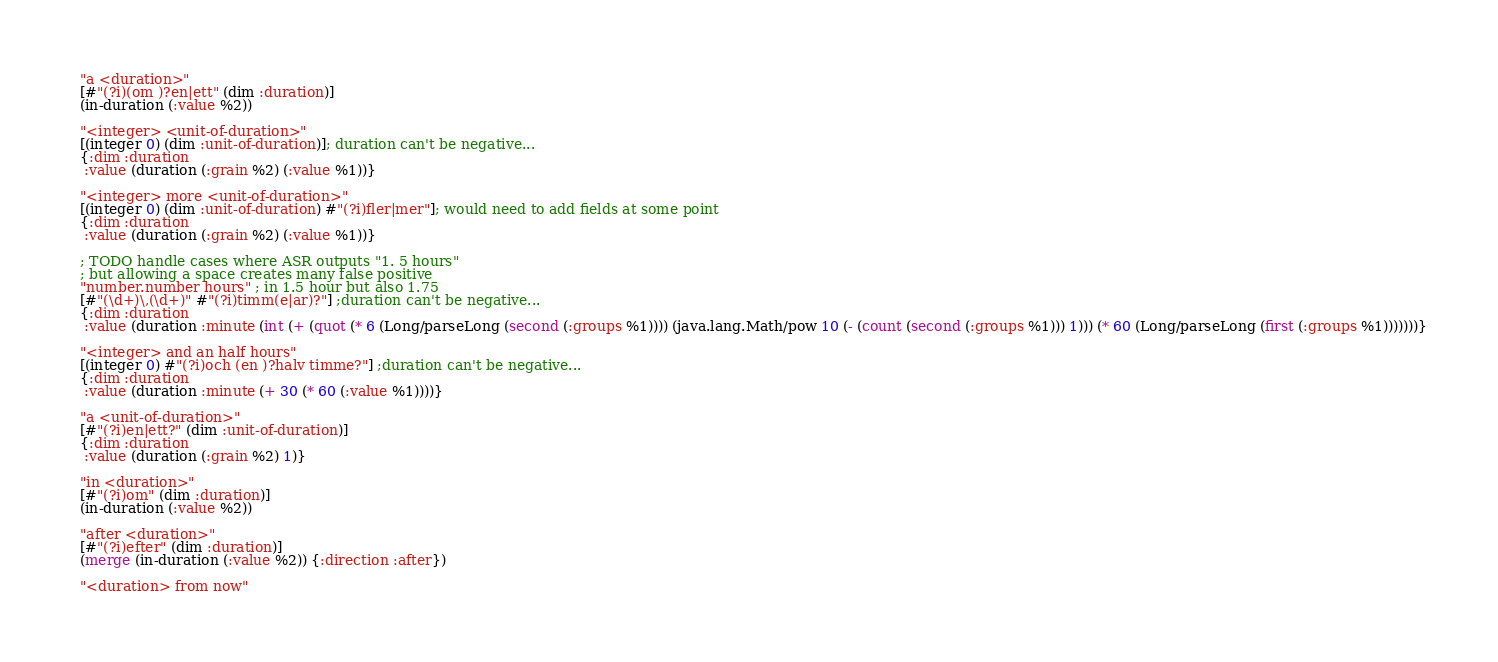Convert code to text. <code><loc_0><loc_0><loc_500><loc_500><_Clojure_>  "a <duration>"
  [#"(?i)(om )?en|ett" (dim :duration)]
  (in-duration (:value %2))

  "<integer> <unit-of-duration>"
  [(integer 0) (dim :unit-of-duration)]; duration can't be negative...
  {:dim :duration
   :value (duration (:grain %2) (:value %1))}

  "<integer> more <unit-of-duration>"
  [(integer 0) (dim :unit-of-duration) #"(?i)fler|mer"]; would need to add fields at some point
  {:dim :duration
   :value (duration (:grain %2) (:value %1))}

  ; TODO handle cases where ASR outputs "1. 5 hours"
  ; but allowing a space creates many false positive
  "number.number hours" ; in 1.5 hour but also 1.75
  [#"(\d+)\,(\d+)" #"(?i)timm(e|ar)?"] ;duration can't be negative...
  {:dim :duration
   :value (duration :minute (int (+ (quot (* 6 (Long/parseLong (second (:groups %1)))) (java.lang.Math/pow 10 (- (count (second (:groups %1))) 1))) (* 60 (Long/parseLong (first (:groups %1)))))))}

  "<integer> and an half hours"
  [(integer 0) #"(?i)och (en )?halv timme?"] ;duration can't be negative...
  {:dim :duration
   :value (duration :minute (+ 30 (* 60 (:value %1))))}

  "a <unit-of-duration>"
  [#"(?i)en|ett?" (dim :unit-of-duration)]
  {:dim :duration
   :value (duration (:grain %2) 1)}

  "in <duration>"
  [#"(?i)om" (dim :duration)]
  (in-duration (:value %2))

  "after <duration>"
  [#"(?i)efter" (dim :duration)]
  (merge (in-duration (:value %2)) {:direction :after})

  "<duration> from now"</code> 